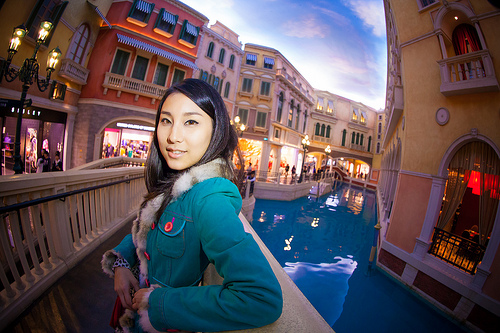<image>
Is the lamp in front of the window? No. The lamp is not in front of the window. The spatial positioning shows a different relationship between these objects. 